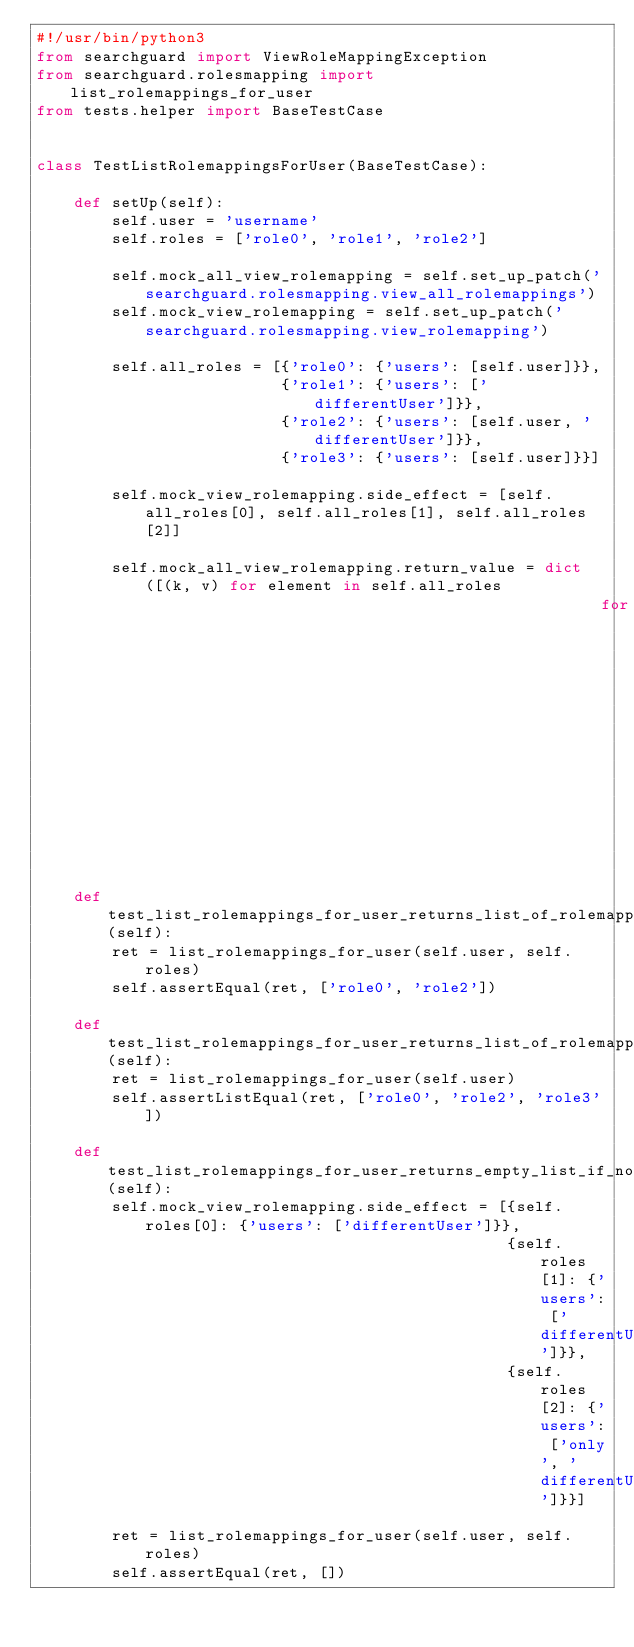Convert code to text. <code><loc_0><loc_0><loc_500><loc_500><_Python_>#!/usr/bin/python3
from searchguard import ViewRoleMappingException
from searchguard.rolesmapping import list_rolemappings_for_user
from tests.helper import BaseTestCase


class TestListRolemappingsForUser(BaseTestCase):

    def setUp(self):
        self.user = 'username'
        self.roles = ['role0', 'role1', 'role2']

        self.mock_all_view_rolemapping = self.set_up_patch('searchguard.rolesmapping.view_all_rolemappings')
        self.mock_view_rolemapping = self.set_up_patch('searchguard.rolesmapping.view_rolemapping')

        self.all_roles = [{'role0': {'users': [self.user]}},
                          {'role1': {'users': ['differentUser']}},
                          {'role2': {'users': [self.user, 'differentUser']}},
                          {'role3': {'users': [self.user]}}]

        self.mock_view_rolemapping.side_effect = [self.all_roles[0], self.all_roles[1], self.all_roles[2]]

        self.mock_all_view_rolemapping.return_value = dict([(k, v) for element in self.all_roles
                                                            for k, v in element.items()])

    def test_list_rolemappings_for_user_returns_list_of_rolemappings_that_contain_user_for_provided_roles(self):
        ret = list_rolemappings_for_user(self.user, self.roles)
        self.assertEqual(ret, ['role0', 'role2'])

    def test_list_rolemappings_for_user_returns_list_of_rolemappings_that_contain_user_for_all_rolemappings(self):
        ret = list_rolemappings_for_user(self.user)
        self.assertListEqual(ret, ['role0', 'role2', 'role3'])

    def test_list_rolemappings_for_user_returns_empty_list_if_no_matches_occur(self):
        self.mock_view_rolemapping.side_effect = [{self.roles[0]: {'users': ['differentUser']}},
                                                  {self.roles[1]: {'users': ['differentUser']}},
                                                  {self.roles[2]: {'users': ['only', 'differentUser']}}]

        ret = list_rolemappings_for_user(self.user, self.roles)
        self.assertEqual(ret, [])
</code> 